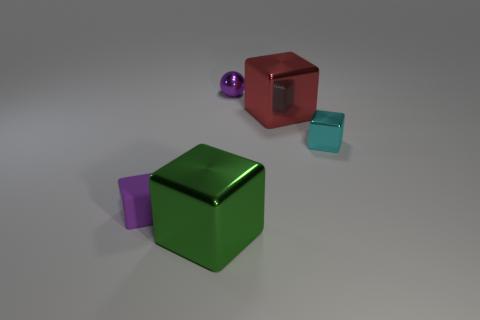Add 3 cyan things. How many objects exist? 8 Subtract all purple blocks. How many blocks are left? 3 Subtract all cyan blocks. How many blocks are left? 3 Subtract 2 cubes. How many cubes are left? 2 Subtract all cubes. How many objects are left? 1 Subtract all brown cubes. Subtract all green cylinders. How many cubes are left? 4 Add 3 purple matte things. How many purple matte things exist? 4 Subtract 0 cyan cylinders. How many objects are left? 5 Subtract all small matte objects. Subtract all green shiny blocks. How many objects are left? 3 Add 2 small cyan things. How many small cyan things are left? 3 